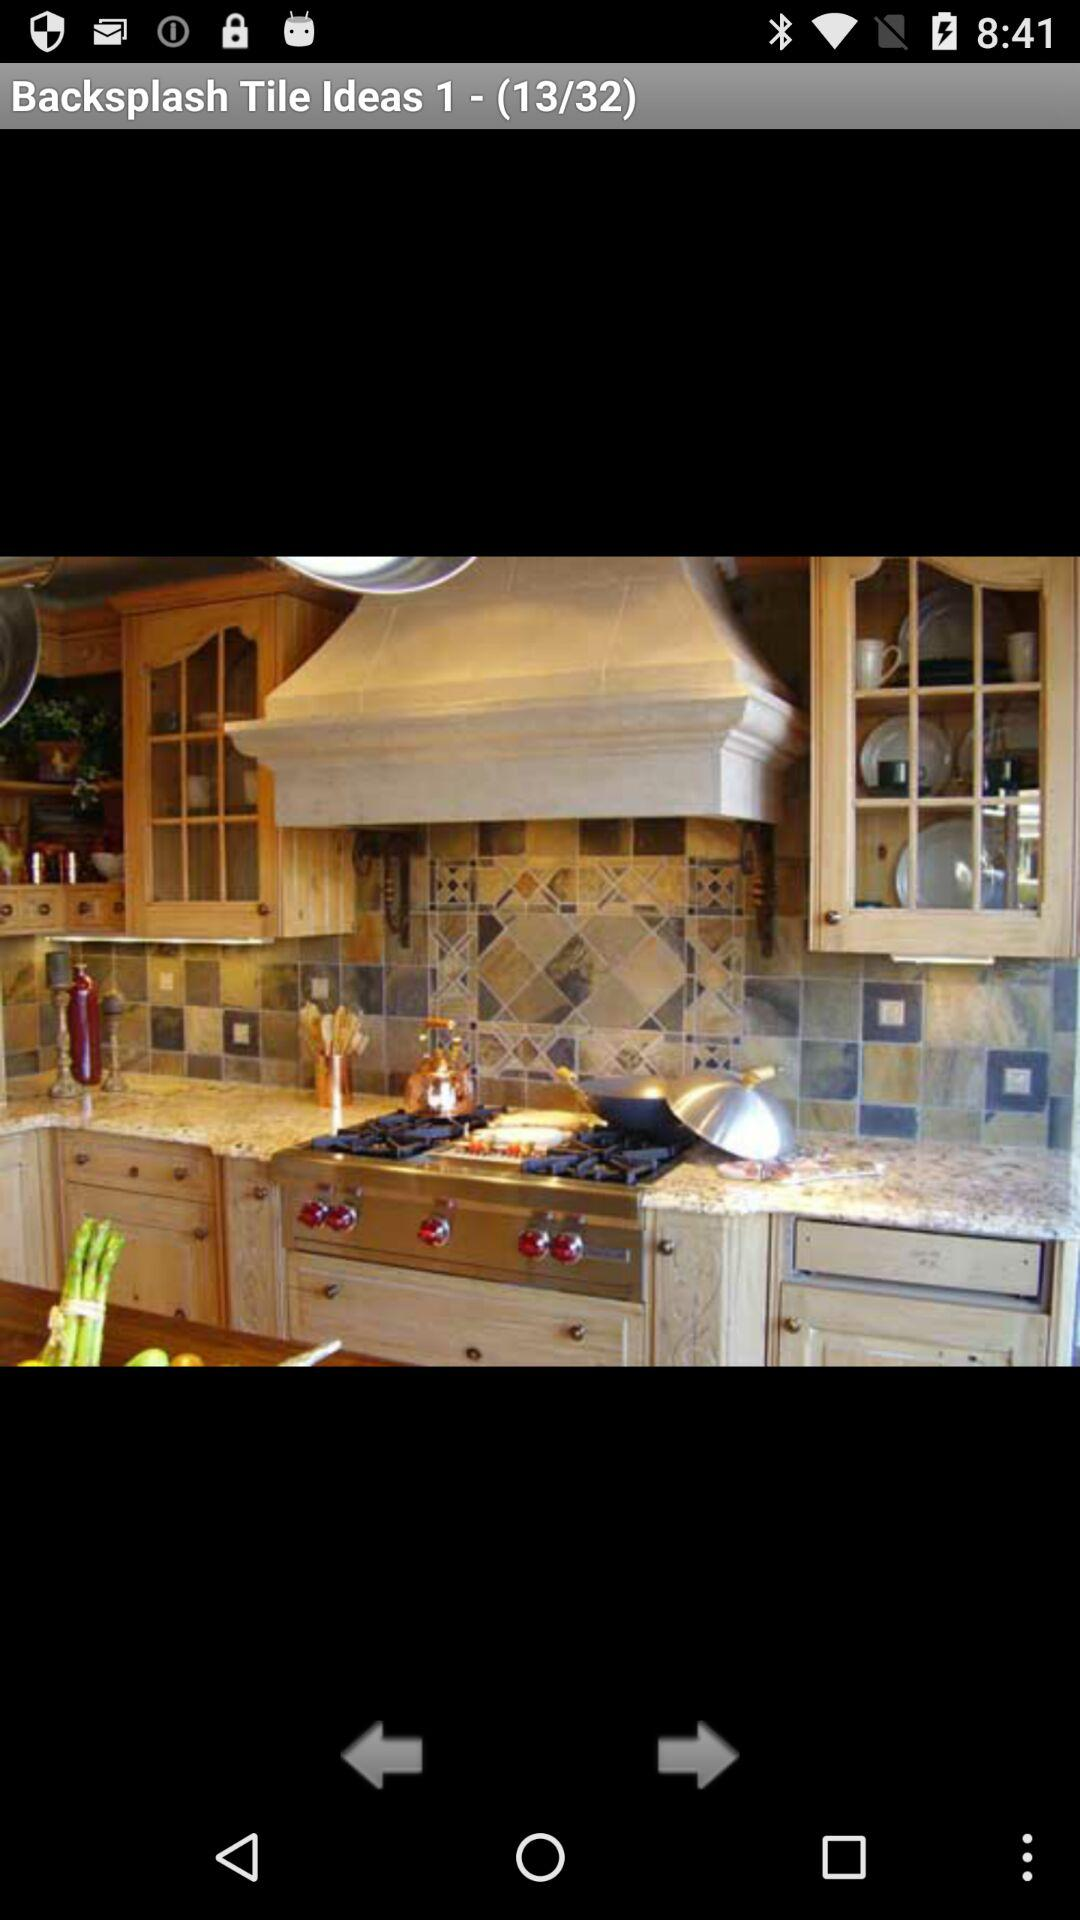What image am I in? You are at 13 image. 